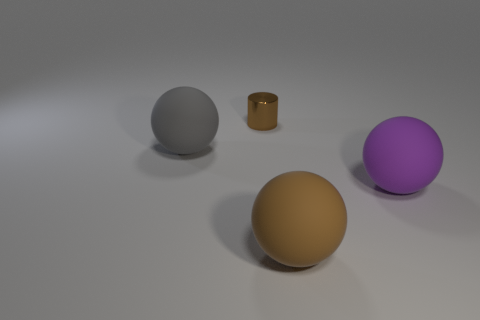Is there anything else that has the same size as the brown cylinder?
Give a very brief answer. No. How many brown objects have the same size as the gray thing?
Offer a terse response. 1. What is the color of the thing behind the large object to the left of the big brown thing?
Offer a very short reply. Brown. Is there another object of the same color as the small object?
Offer a terse response. Yes. Do the large sphere to the left of the tiny brown shiny cylinder and the large brown sphere have the same material?
Make the answer very short. Yes. There is a large object that is left of the rubber sphere that is in front of the large purple rubber object; is there a object that is behind it?
Provide a short and direct response. Yes. Does the big rubber object that is in front of the big purple sphere have the same shape as the large gray thing?
Keep it short and to the point. Yes. The brown thing in front of the big thing behind the large purple rubber thing is what shape?
Give a very brief answer. Sphere. There is a brown object that is behind the brown thing that is in front of the matte object to the left of the small shiny object; how big is it?
Provide a succinct answer. Small. Does the gray ball have the same size as the purple sphere?
Offer a very short reply. Yes. 